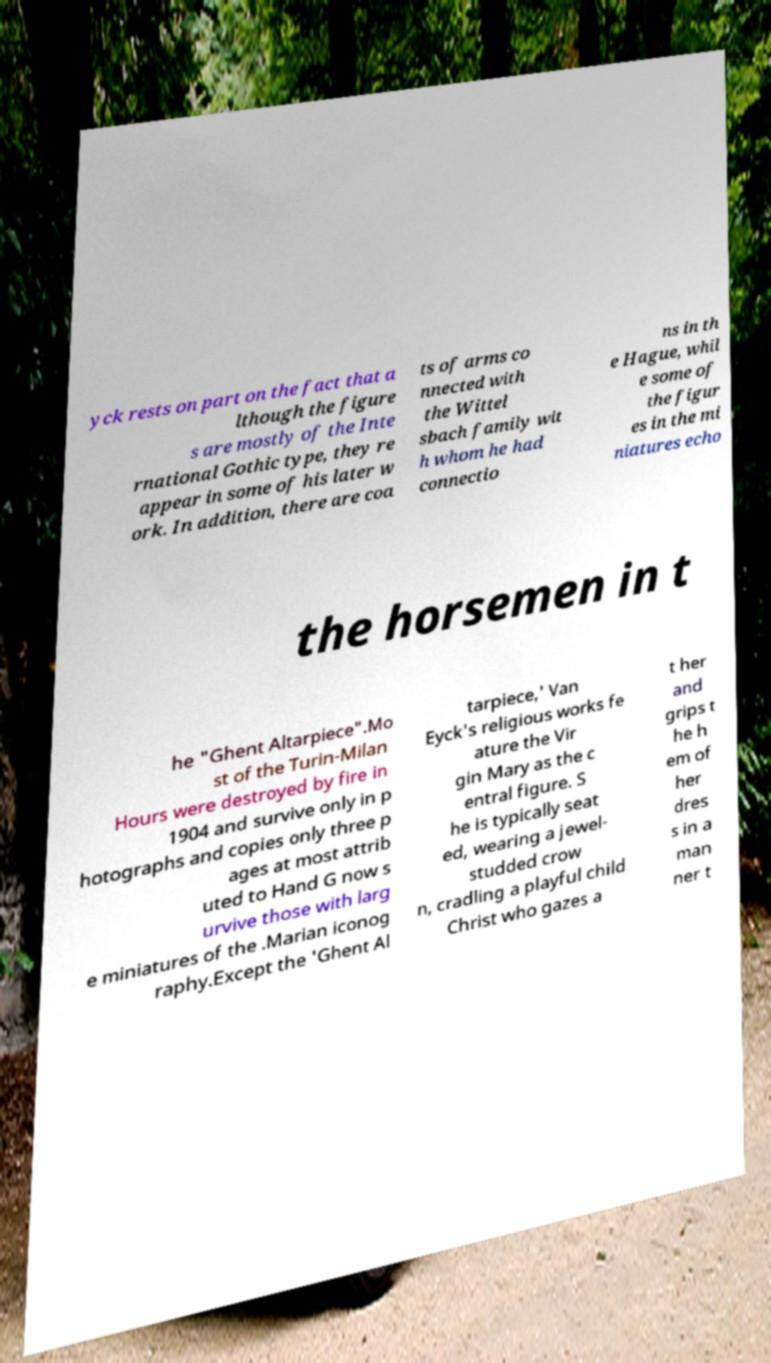Please identify and transcribe the text found in this image. yck rests on part on the fact that a lthough the figure s are mostly of the Inte rnational Gothic type, they re appear in some of his later w ork. In addition, there are coa ts of arms co nnected with the Wittel sbach family wit h whom he had connectio ns in th e Hague, whil e some of the figur es in the mi niatures echo the horsemen in t he "Ghent Altarpiece".Mo st of the Turin-Milan Hours were destroyed by fire in 1904 and survive only in p hotographs and copies only three p ages at most attrib uted to Hand G now s urvive those with larg e miniatures of the .Marian iconog raphy.Except the 'Ghent Al tarpiece,' Van Eyck's religious works fe ature the Vir gin Mary as the c entral figure. S he is typically seat ed, wearing a jewel- studded crow n, cradling a playful child Christ who gazes a t her and grips t he h em of her dres s in a man ner t 